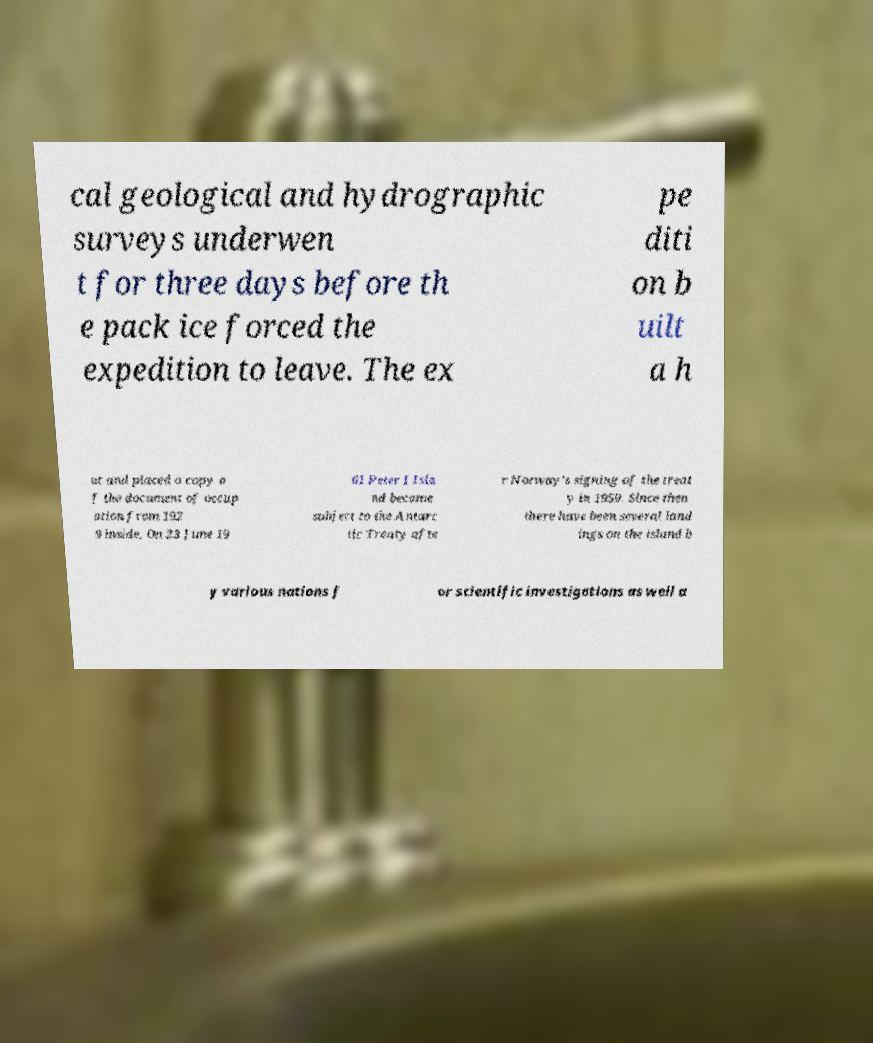Can you read and provide the text displayed in the image?This photo seems to have some interesting text. Can you extract and type it out for me? cal geological and hydrographic surveys underwen t for three days before th e pack ice forced the expedition to leave. The ex pe diti on b uilt a h ut and placed a copy o f the document of occup ation from 192 9 inside. On 23 June 19 61 Peter I Isla nd became subject to the Antarc tic Treaty afte r Norway's signing of the treat y in 1959. Since then there have been several land ings on the island b y various nations f or scientific investigations as well a 